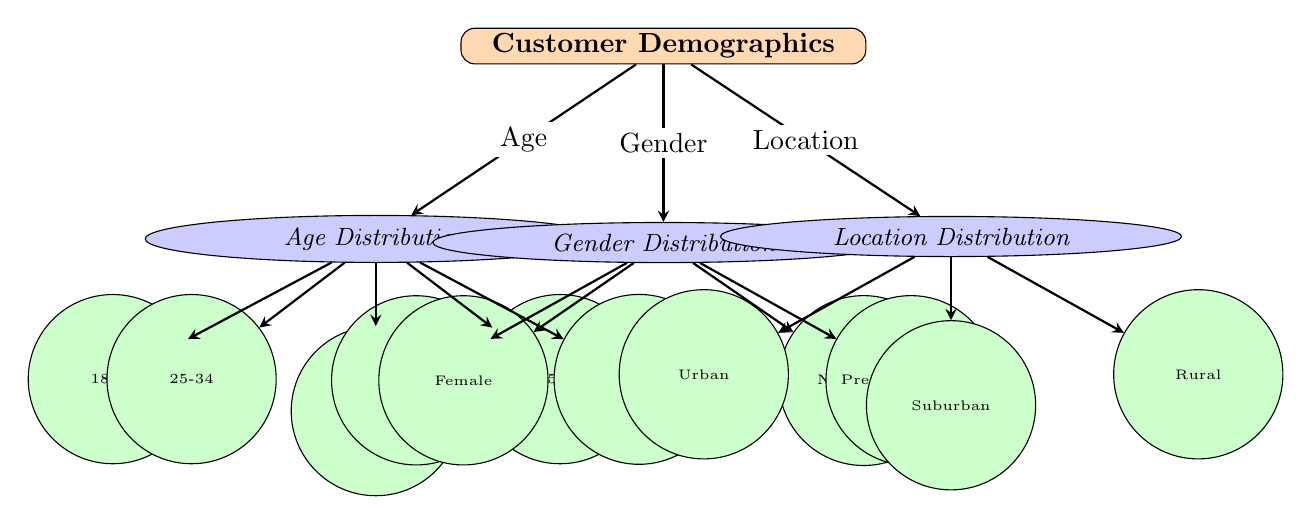What are the three main categories of customer demographics? The diagram identifies three main categories: Age Distribution, Gender Distribution, and Location Distribution. These categories are indicated as sub-nodes stemming directly from the main node labeled "Customer Demographics."
Answer: Age Distribution, Gender Distribution, Location Distribution How many age groups are represented in the diagram? The diagram outlines five age groups: 18-24, 25-34, 35-44, 45-54, and 55+. These groups are categorized under the sub-node for Age Distribution, making a total of five distinct age groups.
Answer: 5 What gender identities are included in the gender distribution? The diagram includes four gender identities: Male, Female, Non-binary, and Prefer not to say. These identities are shown as detail nodes under the Gender Distribution sub-node.
Answer: Male, Female, Non-binary, Prefer not to say Which demographic category has the most detailed subdivisions? The Age Distribution category has the most subdivisions, with five different age groups specified. This number exceeds the subdivisions under both Gender Distribution (four identities) and Location Distribution (three areas).
Answer: Age Distribution Is there a gender identity included that allows participants to opt-out of answering? Yes, the category "Prefer not to say" allows respondents to opt-out of specifying their gender identity. This option is listed as one of the detail nodes under the Gender Distribution.
Answer: Prefer not to say How many location types are represented in the diagram? The diagram represents three location types: Urban, Suburban, and Rural. These locations are specified as detail nodes under the Location Distribution.
Answer: 3 What type of relationships are depicted between the main node and sub-nodes? The relationships between the main node "Customer Demographics" and its sub-nodes (Age, Gender, Location) are represented by directed edges, indicating that these sub-nodes are components of the overall demographic analysis.
Answer: Directed edges Which demographic category contains the widest age range? The Age Distribution category contains a range that varies from 18-24 to 55+, indicating the widest range of ages represented in the categories.
Answer: Age Distribution How are the details of each demographic aspect connected to their corresponding categories? Each demographic aspect (Age, Gender, Location) has detailed nodes connected to their respective categories through edges, illustrating how the details are part of the overall demographic structure of the brewery's customer base.
Answer: Through edges 